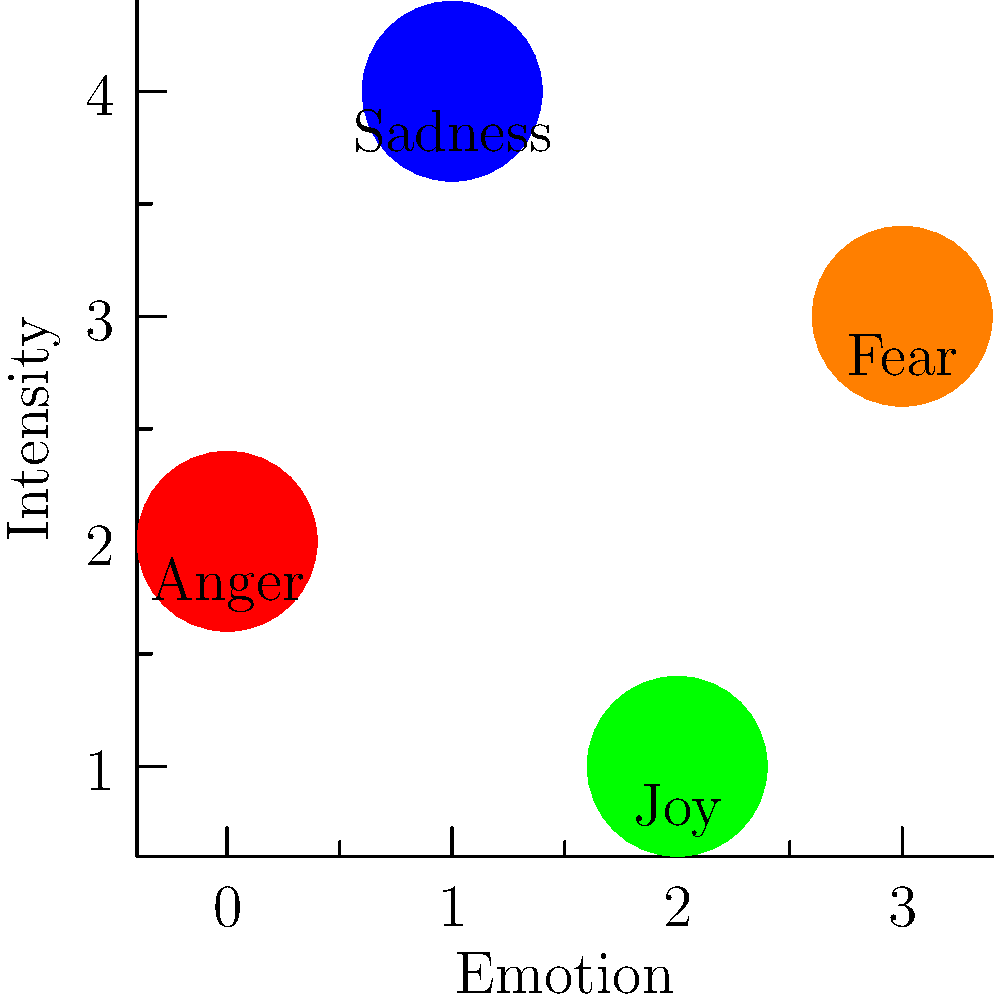Based on the emotional intensity chart above, which emotion might be most challenging for a recovering addict to manage during periods of intense cravings? To answer this question, we need to analyze the emotional intensity chart and consider the context of addiction recovery:

1. The chart shows four emotions: Anger, Sadness, Joy, and Fear.
2. The vertical axis represents the intensity of each emotion.
3. Anger has the highest intensity (4 on the scale).
4. Sadness is the second highest (3 on the scale).
5. Fear is moderate (2 on the scale).
6. Joy has the lowest intensity (1 on the scale).

In the context of addiction recovery and cravings:
- Anger is often associated with frustration and impulsivity, which can lead to poor decision-making.
- High-intensity emotions are generally more challenging to manage during recovery.
- Intense anger can trigger relapse as individuals may seek substances to cope with or suppress this emotion.

Therefore, based on its high intensity and potential impact on recovery, anger would likely be the most challenging emotion to manage during periods of intense cravings.
Answer: Anger 